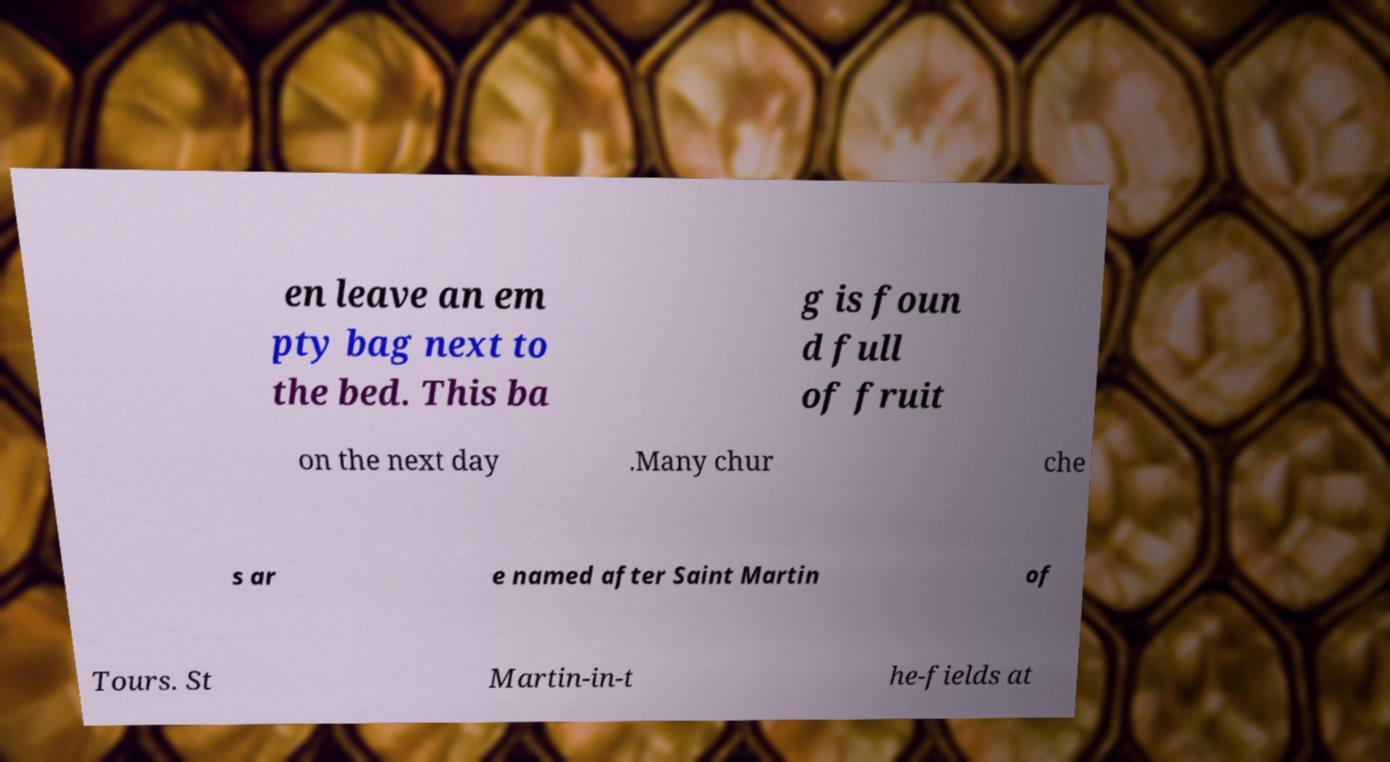There's text embedded in this image that I need extracted. Can you transcribe it verbatim? en leave an em pty bag next to the bed. This ba g is foun d full of fruit on the next day .Many chur che s ar e named after Saint Martin of Tours. St Martin-in-t he-fields at 